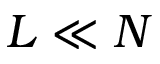<formula> <loc_0><loc_0><loc_500><loc_500>L \ll N</formula> 